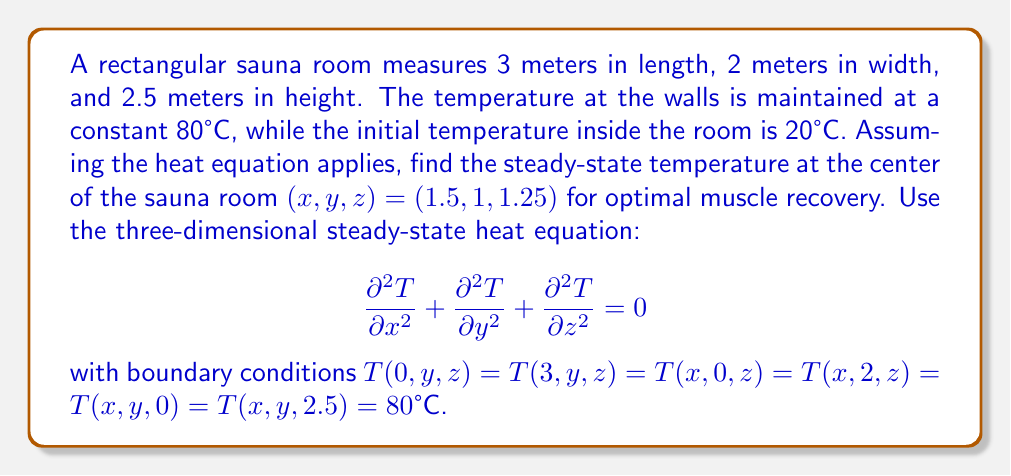Can you answer this question? To solve this problem, we'll use the method of separation of variables for the three-dimensional steady-state heat equation.

Step 1: Assume the solution has the form $T(x,y,z) = X(x)Y(y)Z(z)$.

Step 2: Substitute this into the heat equation:
$$X''YZ + XY''Z + XYZ'' = 0$$
$$\frac{X''}{X} + \frac{Y''}{Y} + \frac{Z''}{Z} = 0$$

Step 3: Each term must equal a constant. Let $\frac{X''}{X} = -\alpha^2$, $\frac{Y''}{Y} = -\beta^2$, and $\frac{Z''}{Z} = -\gamma^2$, where $\alpha^2 + \beta^2 + \gamma^2 = 0$.

Step 4: Solve the resulting ODEs:
$$X(x) = A \sin(\alpha x) + B \cos(\alpha x)$$
$$Y(y) = C \sin(\beta y) + D \cos(\beta y)$$
$$Z(z) = E \sin(\gamma z) + F \cos(\gamma z)$$

Step 5: Apply boundary conditions:
$X(0) = X(3) = 80°C$ implies $\alpha = \frac{n\pi}{3}$, $n = 1,2,3,...$
$Y(0) = Y(2) = 80°C$ implies $\beta = \frac{m\pi}{2}$, $m = 1,2,3,...$
$Z(0) = Z(2.5) = 80°C$ implies $\gamma = \frac{k\pi}{2.5}$, $k = 1,2,3,...$

Step 6: The general solution is:
$$T(x,y,z) = 80 + \sum_{n=1}^{\infty}\sum_{m=1}^{\infty}\sum_{k=1}^{\infty} A_{nmk} \sin(\frac{n\pi x}{3}) \sin(\frac{m\pi y}{2}) \sin(\frac{k\pi z}{2.5})$$

Step 7: The coefficients $A_{nmk}$ can be determined using the initial condition, but for the steady-state solution, we only need the constant term 80°C.

Step 8: At the center of the room $(1.5, 1, 1.25)$, all sine terms evaluate to zero except when $n$, $m$, and $k$ are odd.

Therefore, the steady-state temperature at the center of the sauna room is 80°C.
Answer: 80°C 